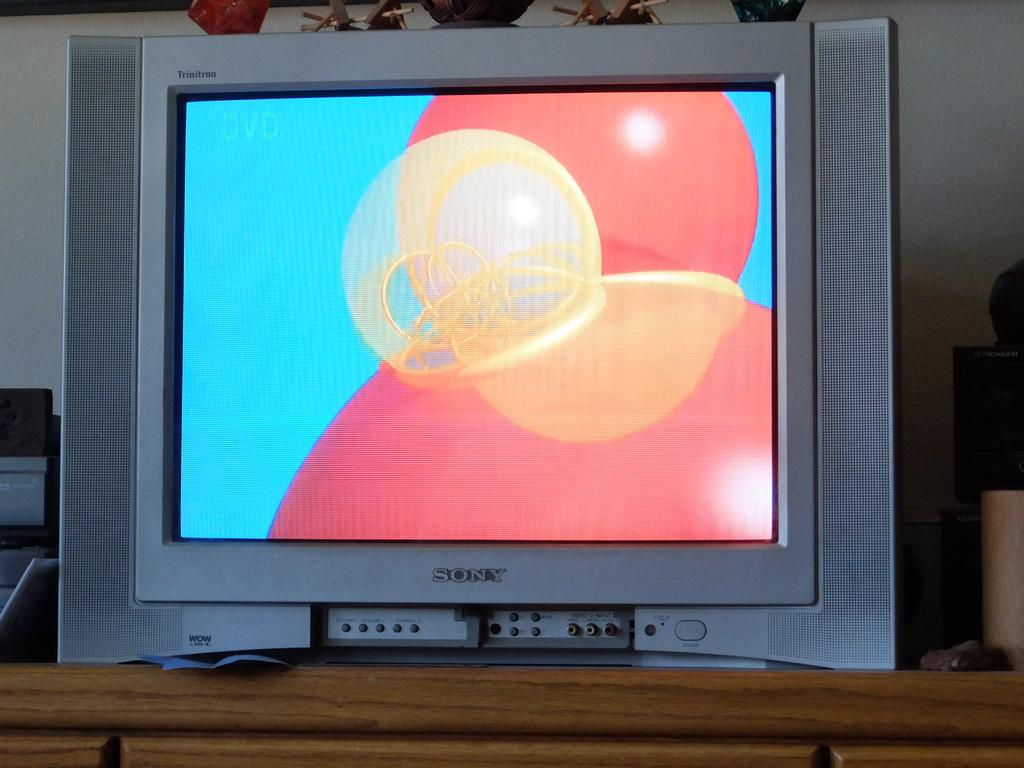<image>
Render a clear and concise summary of the photo. A Sony Trinitron television is sitting on the dresser. 